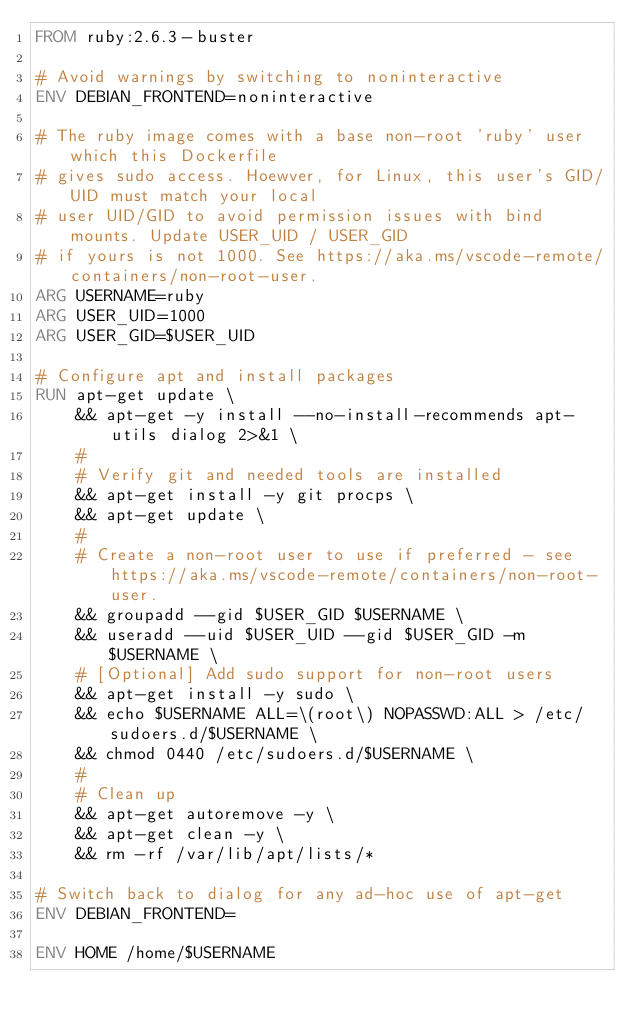Convert code to text. <code><loc_0><loc_0><loc_500><loc_500><_Dockerfile_>FROM ruby:2.6.3-buster

# Avoid warnings by switching to noninteractive
ENV DEBIAN_FRONTEND=noninteractive

# The ruby image comes with a base non-root 'ruby' user which this Dockerfile
# gives sudo access. Hoewver, for Linux, this user's GID/UID must match your local
# user UID/GID to avoid permission issues with bind mounts. Update USER_UID / USER_GID
# if yours is not 1000. See https://aka.ms/vscode-remote/containers/non-root-user.
ARG USERNAME=ruby
ARG USER_UID=1000
ARG USER_GID=$USER_UID

# Configure apt and install packages
RUN apt-get update \
    && apt-get -y install --no-install-recommends apt-utils dialog 2>&1 \
    #
    # Verify git and needed tools are installed
    && apt-get install -y git procps \
    && apt-get update \
    #
    # Create a non-root user to use if preferred - see https://aka.ms/vscode-remote/containers/non-root-user.
    && groupadd --gid $USER_GID $USERNAME \
    && useradd --uid $USER_UID --gid $USER_GID -m $USERNAME \
    # [Optional] Add sudo support for non-root users
    && apt-get install -y sudo \
    && echo $USERNAME ALL=\(root\) NOPASSWD:ALL > /etc/sudoers.d/$USERNAME \
    && chmod 0440 /etc/sudoers.d/$USERNAME \
    #
    # Clean up
    && apt-get autoremove -y \
    && apt-get clean -y \
    && rm -rf /var/lib/apt/lists/*

# Switch back to dialog for any ad-hoc use of apt-get
ENV DEBIAN_FRONTEND=

ENV HOME /home/$USERNAME</code> 